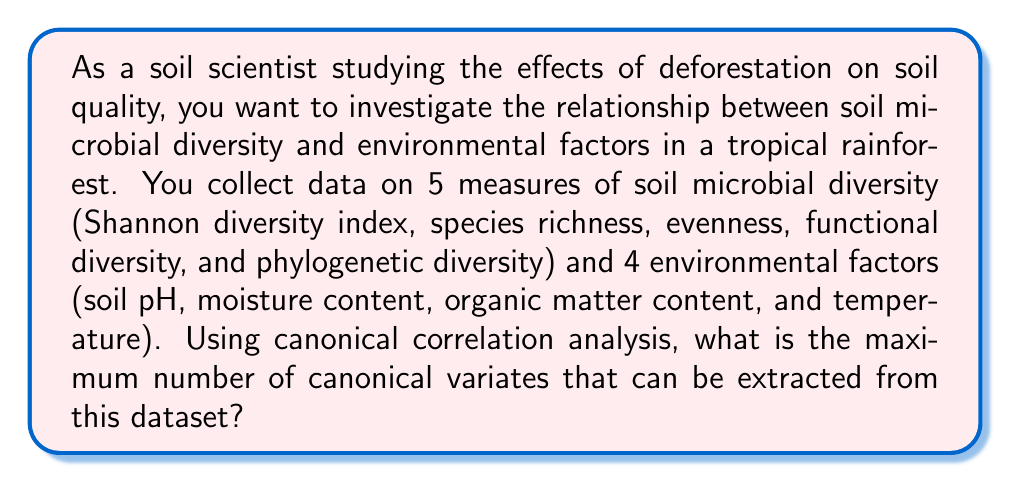Show me your answer to this math problem. To determine the maximum number of canonical variates in a canonical correlation analysis (CCA), we need to consider the number of variables in each set:

1. Set 1 (Soil microbial diversity measures): $p = 5$
2. Set 2 (Environmental factors): $q = 4$

The maximum number of canonical variates is equal to the minimum of $p$ and $q$:

$$ \text{Max number of canonical variates} = \min(p, q) $$

In this case:

$$ \min(5, 4) = 4 $$

The reason for this is that canonical correlation analysis aims to find linear combinations of variables in each set that maximize the correlation between the two sets. The number of these linear combinations (canonical variates) is limited by the smaller of the two sets, as we cannot create more independent linear combinations than the number of variables in the smaller set.

Each canonical variate represents a dimension of the relationship between the two sets of variables. The first canonical variate accounts for the highest correlation between the sets, the second accounts for the next highest correlation (orthogonal to the first), and so on.

In the context of soil science and deforestation studies, these canonical variates would represent different aspects of how soil microbial diversity relates to environmental factors, potentially revealing complex interactions that could be affected by deforestation.
Answer: The maximum number of canonical variates that can be extracted is 4. 